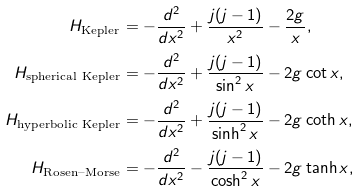Convert formula to latex. <formula><loc_0><loc_0><loc_500><loc_500>H _ { \text {Kepler} } & = - \frac { d ^ { 2 } } { d x ^ { 2 } } + \frac { j ( j - 1 ) } { x ^ { 2 } } - \frac { 2 g } { x } , \\ H _ { \text {spherical Kepler} } & = - \frac { d ^ { 2 } } { d x ^ { 2 } } + \frac { j ( j - 1 ) } { \sin ^ { 2 } x } - 2 g \cot x , \\ H _ { \text {hyperbolic Kepler} } & = - \frac { d ^ { 2 } } { d x ^ { 2 } } + \frac { j ( j - 1 ) } { \sinh ^ { 2 } x } - 2 g \coth x , \\ H _ { \text {Rosen--Morse} } & = - \frac { d ^ { 2 } } { d x ^ { 2 } } - \frac { j ( j - 1 ) } { \cosh ^ { 2 } x } - 2 g \tanh x ,</formula> 